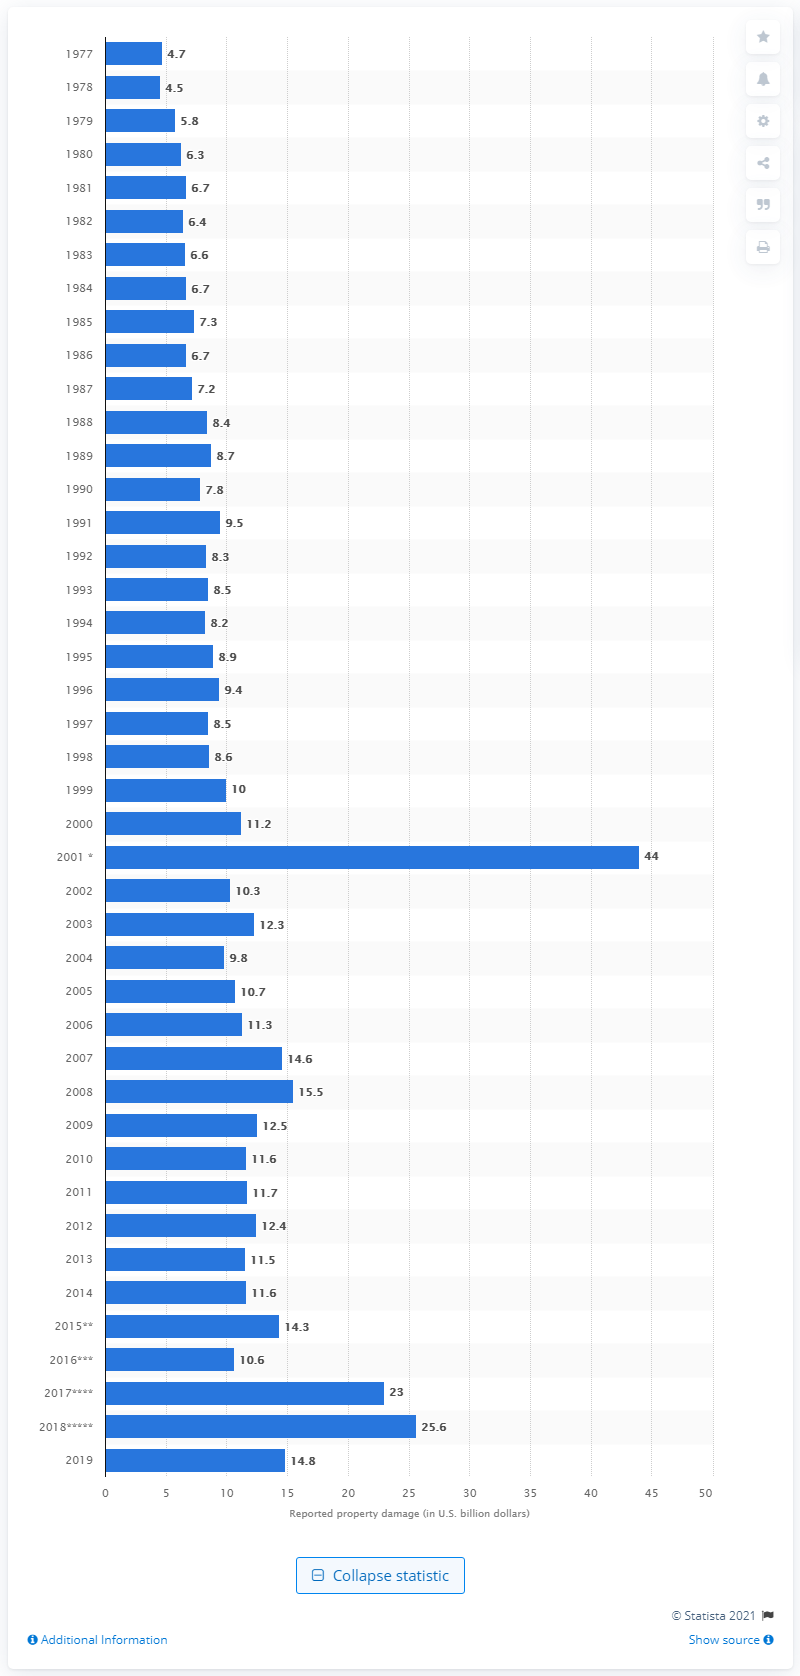Specify some key components in this picture. In 2019, the United States experienced 14.8 billion dollars in property damage due to fires. According to the United States in 2018, fires caused 25.6 million dollars in damage. 